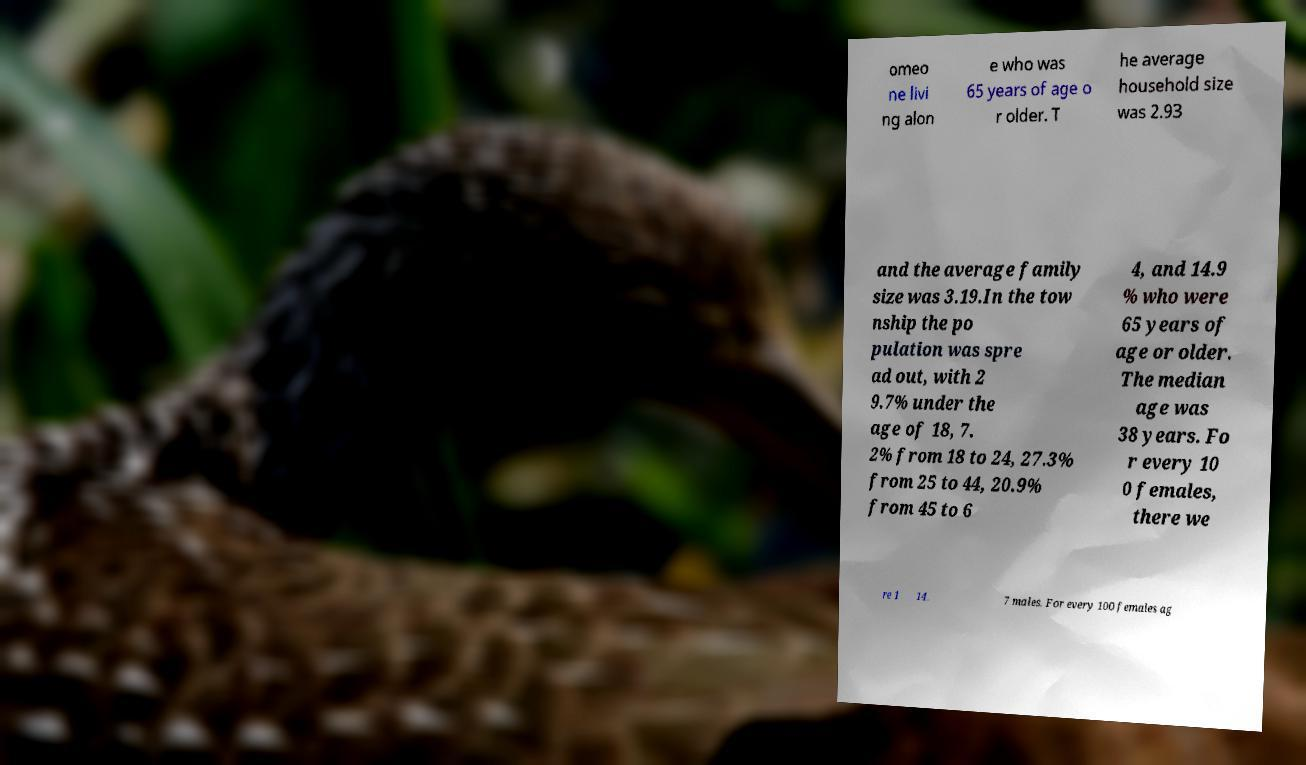What messages or text are displayed in this image? I need them in a readable, typed format. omeo ne livi ng alon e who was 65 years of age o r older. T he average household size was 2.93 and the average family size was 3.19.In the tow nship the po pulation was spre ad out, with 2 9.7% under the age of 18, 7. 2% from 18 to 24, 27.3% from 25 to 44, 20.9% from 45 to 6 4, and 14.9 % who were 65 years of age or older. The median age was 38 years. Fo r every 10 0 females, there we re 1 14. 7 males. For every 100 females ag 